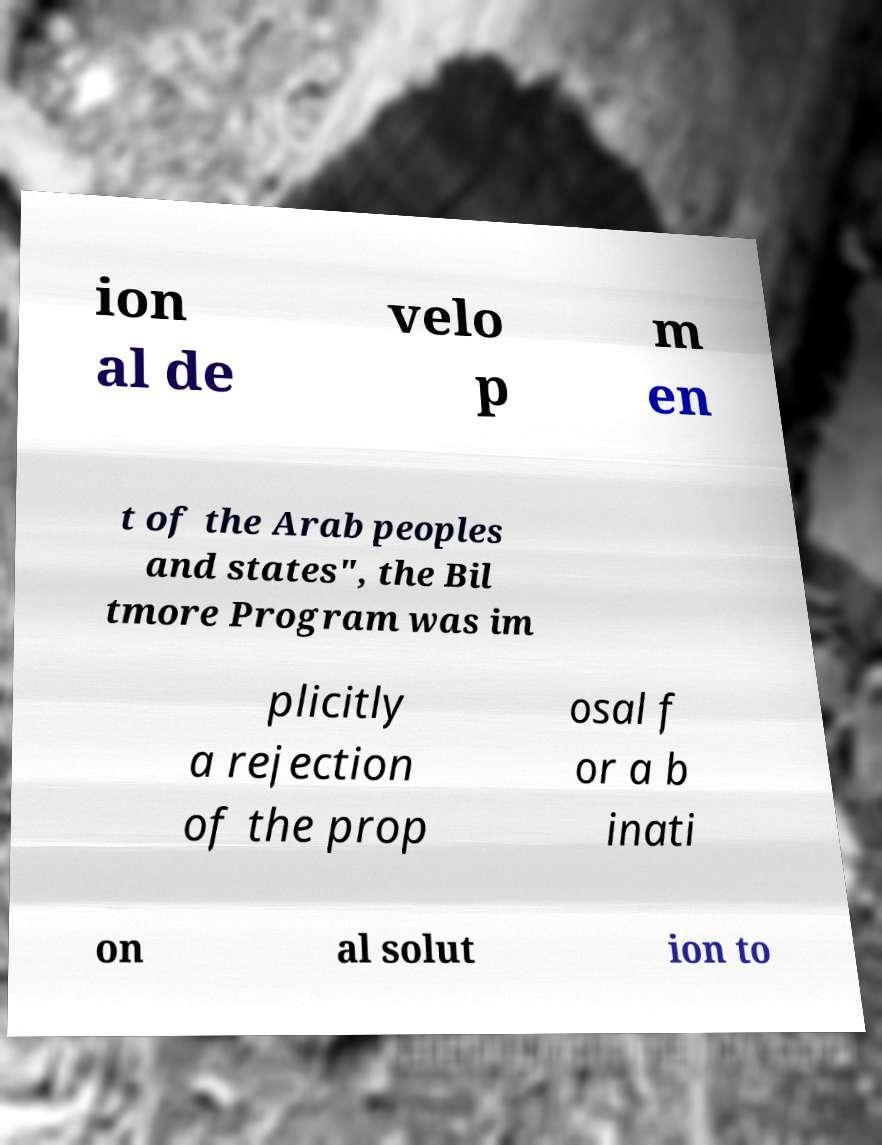Could you extract and type out the text from this image? ion al de velo p m en t of the Arab peoples and states", the Bil tmore Program was im plicitly a rejection of the prop osal f or a b inati on al solut ion to 